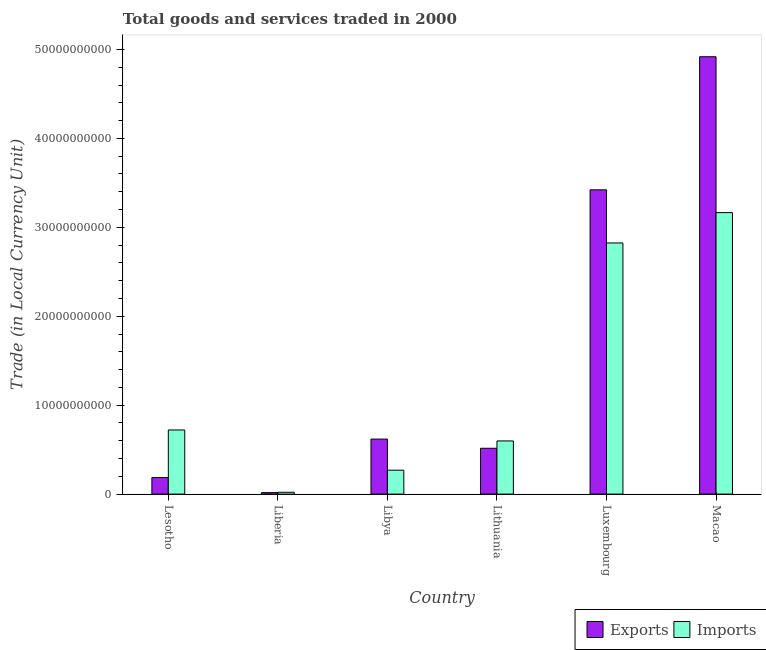How many different coloured bars are there?
Your response must be concise. 2. Are the number of bars on each tick of the X-axis equal?
Your response must be concise. Yes. How many bars are there on the 6th tick from the left?
Give a very brief answer. 2. How many bars are there on the 5th tick from the right?
Your answer should be very brief. 2. What is the label of the 5th group of bars from the left?
Ensure brevity in your answer.  Luxembourg. What is the export of goods and services in Luxembourg?
Your answer should be compact. 3.42e+1. Across all countries, what is the maximum imports of goods and services?
Keep it short and to the point. 3.17e+1. Across all countries, what is the minimum export of goods and services?
Your answer should be compact. 1.66e+08. In which country was the export of goods and services maximum?
Provide a succinct answer. Macao. In which country was the export of goods and services minimum?
Provide a short and direct response. Liberia. What is the total export of goods and services in the graph?
Provide a short and direct response. 9.68e+1. What is the difference between the export of goods and services in Lithuania and that in Luxembourg?
Give a very brief answer. -2.91e+1. What is the difference between the imports of goods and services in Luxembourg and the export of goods and services in Liberia?
Your answer should be compact. 2.81e+1. What is the average imports of goods and services per country?
Keep it short and to the point. 1.27e+1. What is the difference between the export of goods and services and imports of goods and services in Macao?
Offer a terse response. 1.75e+1. In how many countries, is the imports of goods and services greater than 34000000000 LCU?
Provide a succinct answer. 0. What is the ratio of the imports of goods and services in Lesotho to that in Lithuania?
Make the answer very short. 1.21. Is the imports of goods and services in Lithuania less than that in Luxembourg?
Your response must be concise. Yes. Is the difference between the imports of goods and services in Lesotho and Lithuania greater than the difference between the export of goods and services in Lesotho and Lithuania?
Provide a short and direct response. Yes. What is the difference between the highest and the second highest imports of goods and services?
Make the answer very short. 3.41e+09. What is the difference between the highest and the lowest export of goods and services?
Offer a very short reply. 4.90e+1. In how many countries, is the imports of goods and services greater than the average imports of goods and services taken over all countries?
Offer a very short reply. 2. What does the 1st bar from the left in Lithuania represents?
Give a very brief answer. Exports. What does the 2nd bar from the right in Libya represents?
Provide a succinct answer. Exports. How many countries are there in the graph?
Your response must be concise. 6. What is the difference between two consecutive major ticks on the Y-axis?
Your answer should be very brief. 1.00e+1. Are the values on the major ticks of Y-axis written in scientific E-notation?
Your response must be concise. No. Does the graph contain any zero values?
Offer a very short reply. No. How many legend labels are there?
Your response must be concise. 2. How are the legend labels stacked?
Ensure brevity in your answer.  Horizontal. What is the title of the graph?
Offer a very short reply. Total goods and services traded in 2000. What is the label or title of the Y-axis?
Keep it short and to the point. Trade (in Local Currency Unit). What is the Trade (in Local Currency Unit) of Exports in Lesotho?
Provide a short and direct response. 1.86e+09. What is the Trade (in Local Currency Unit) in Imports in Lesotho?
Keep it short and to the point. 7.21e+09. What is the Trade (in Local Currency Unit) in Exports in Liberia?
Provide a succinct answer. 1.66e+08. What is the Trade (in Local Currency Unit) of Imports in Liberia?
Give a very brief answer. 2.06e+08. What is the Trade (in Local Currency Unit) in Exports in Libya?
Your answer should be compact. 6.19e+09. What is the Trade (in Local Currency Unit) of Imports in Libya?
Provide a succinct answer. 2.69e+09. What is the Trade (in Local Currency Unit) of Exports in Lithuania?
Offer a terse response. 5.15e+09. What is the Trade (in Local Currency Unit) of Imports in Lithuania?
Offer a very short reply. 5.98e+09. What is the Trade (in Local Currency Unit) in Exports in Luxembourg?
Make the answer very short. 3.42e+1. What is the Trade (in Local Currency Unit) in Imports in Luxembourg?
Give a very brief answer. 2.82e+1. What is the Trade (in Local Currency Unit) in Exports in Macao?
Your answer should be compact. 4.92e+1. What is the Trade (in Local Currency Unit) in Imports in Macao?
Your answer should be very brief. 3.17e+1. Across all countries, what is the maximum Trade (in Local Currency Unit) in Exports?
Give a very brief answer. 4.92e+1. Across all countries, what is the maximum Trade (in Local Currency Unit) of Imports?
Provide a succinct answer. 3.17e+1. Across all countries, what is the minimum Trade (in Local Currency Unit) in Exports?
Offer a very short reply. 1.66e+08. Across all countries, what is the minimum Trade (in Local Currency Unit) in Imports?
Your response must be concise. 2.06e+08. What is the total Trade (in Local Currency Unit) of Exports in the graph?
Give a very brief answer. 9.68e+1. What is the total Trade (in Local Currency Unit) in Imports in the graph?
Give a very brief answer. 7.60e+1. What is the difference between the Trade (in Local Currency Unit) in Exports in Lesotho and that in Liberia?
Give a very brief answer. 1.70e+09. What is the difference between the Trade (in Local Currency Unit) in Imports in Lesotho and that in Liberia?
Your answer should be compact. 7.00e+09. What is the difference between the Trade (in Local Currency Unit) in Exports in Lesotho and that in Libya?
Ensure brevity in your answer.  -4.32e+09. What is the difference between the Trade (in Local Currency Unit) in Imports in Lesotho and that in Libya?
Give a very brief answer. 4.52e+09. What is the difference between the Trade (in Local Currency Unit) in Exports in Lesotho and that in Lithuania?
Ensure brevity in your answer.  -3.29e+09. What is the difference between the Trade (in Local Currency Unit) in Imports in Lesotho and that in Lithuania?
Provide a short and direct response. 1.23e+09. What is the difference between the Trade (in Local Currency Unit) of Exports in Lesotho and that in Luxembourg?
Provide a succinct answer. -3.23e+1. What is the difference between the Trade (in Local Currency Unit) of Imports in Lesotho and that in Luxembourg?
Provide a succinct answer. -2.10e+1. What is the difference between the Trade (in Local Currency Unit) in Exports in Lesotho and that in Macao?
Keep it short and to the point. -4.73e+1. What is the difference between the Trade (in Local Currency Unit) of Imports in Lesotho and that in Macao?
Your response must be concise. -2.44e+1. What is the difference between the Trade (in Local Currency Unit) of Exports in Liberia and that in Libya?
Give a very brief answer. -6.02e+09. What is the difference between the Trade (in Local Currency Unit) of Imports in Liberia and that in Libya?
Your answer should be compact. -2.48e+09. What is the difference between the Trade (in Local Currency Unit) in Exports in Liberia and that in Lithuania?
Provide a succinct answer. -4.99e+09. What is the difference between the Trade (in Local Currency Unit) in Imports in Liberia and that in Lithuania?
Make the answer very short. -5.77e+09. What is the difference between the Trade (in Local Currency Unit) in Exports in Liberia and that in Luxembourg?
Give a very brief answer. -3.40e+1. What is the difference between the Trade (in Local Currency Unit) of Imports in Liberia and that in Luxembourg?
Offer a very short reply. -2.80e+1. What is the difference between the Trade (in Local Currency Unit) of Exports in Liberia and that in Macao?
Your answer should be compact. -4.90e+1. What is the difference between the Trade (in Local Currency Unit) of Imports in Liberia and that in Macao?
Provide a succinct answer. -3.14e+1. What is the difference between the Trade (in Local Currency Unit) in Exports in Libya and that in Lithuania?
Provide a short and direct response. 1.03e+09. What is the difference between the Trade (in Local Currency Unit) in Imports in Libya and that in Lithuania?
Give a very brief answer. -3.29e+09. What is the difference between the Trade (in Local Currency Unit) of Exports in Libya and that in Luxembourg?
Offer a terse response. -2.80e+1. What is the difference between the Trade (in Local Currency Unit) of Imports in Libya and that in Luxembourg?
Ensure brevity in your answer.  -2.55e+1. What is the difference between the Trade (in Local Currency Unit) in Exports in Libya and that in Macao?
Provide a short and direct response. -4.30e+1. What is the difference between the Trade (in Local Currency Unit) in Imports in Libya and that in Macao?
Your answer should be compact. -2.90e+1. What is the difference between the Trade (in Local Currency Unit) of Exports in Lithuania and that in Luxembourg?
Offer a very short reply. -2.91e+1. What is the difference between the Trade (in Local Currency Unit) in Imports in Lithuania and that in Luxembourg?
Provide a succinct answer. -2.23e+1. What is the difference between the Trade (in Local Currency Unit) of Exports in Lithuania and that in Macao?
Provide a succinct answer. -4.40e+1. What is the difference between the Trade (in Local Currency Unit) of Imports in Lithuania and that in Macao?
Offer a terse response. -2.57e+1. What is the difference between the Trade (in Local Currency Unit) in Exports in Luxembourg and that in Macao?
Keep it short and to the point. -1.50e+1. What is the difference between the Trade (in Local Currency Unit) in Imports in Luxembourg and that in Macao?
Keep it short and to the point. -3.41e+09. What is the difference between the Trade (in Local Currency Unit) in Exports in Lesotho and the Trade (in Local Currency Unit) in Imports in Liberia?
Make the answer very short. 1.66e+09. What is the difference between the Trade (in Local Currency Unit) of Exports in Lesotho and the Trade (in Local Currency Unit) of Imports in Libya?
Your response must be concise. -8.25e+08. What is the difference between the Trade (in Local Currency Unit) of Exports in Lesotho and the Trade (in Local Currency Unit) of Imports in Lithuania?
Your answer should be very brief. -4.11e+09. What is the difference between the Trade (in Local Currency Unit) in Exports in Lesotho and the Trade (in Local Currency Unit) in Imports in Luxembourg?
Your answer should be compact. -2.64e+1. What is the difference between the Trade (in Local Currency Unit) of Exports in Lesotho and the Trade (in Local Currency Unit) of Imports in Macao?
Keep it short and to the point. -2.98e+1. What is the difference between the Trade (in Local Currency Unit) in Exports in Liberia and the Trade (in Local Currency Unit) in Imports in Libya?
Offer a terse response. -2.52e+09. What is the difference between the Trade (in Local Currency Unit) of Exports in Liberia and the Trade (in Local Currency Unit) of Imports in Lithuania?
Ensure brevity in your answer.  -5.81e+09. What is the difference between the Trade (in Local Currency Unit) of Exports in Liberia and the Trade (in Local Currency Unit) of Imports in Luxembourg?
Offer a terse response. -2.81e+1. What is the difference between the Trade (in Local Currency Unit) of Exports in Liberia and the Trade (in Local Currency Unit) of Imports in Macao?
Your response must be concise. -3.15e+1. What is the difference between the Trade (in Local Currency Unit) in Exports in Libya and the Trade (in Local Currency Unit) in Imports in Lithuania?
Provide a short and direct response. 2.07e+08. What is the difference between the Trade (in Local Currency Unit) of Exports in Libya and the Trade (in Local Currency Unit) of Imports in Luxembourg?
Give a very brief answer. -2.21e+1. What is the difference between the Trade (in Local Currency Unit) of Exports in Libya and the Trade (in Local Currency Unit) of Imports in Macao?
Make the answer very short. -2.55e+1. What is the difference between the Trade (in Local Currency Unit) in Exports in Lithuania and the Trade (in Local Currency Unit) in Imports in Luxembourg?
Your response must be concise. -2.31e+1. What is the difference between the Trade (in Local Currency Unit) in Exports in Lithuania and the Trade (in Local Currency Unit) in Imports in Macao?
Offer a very short reply. -2.65e+1. What is the difference between the Trade (in Local Currency Unit) in Exports in Luxembourg and the Trade (in Local Currency Unit) in Imports in Macao?
Offer a very short reply. 2.56e+09. What is the average Trade (in Local Currency Unit) in Exports per country?
Give a very brief answer. 1.61e+1. What is the average Trade (in Local Currency Unit) of Imports per country?
Make the answer very short. 1.27e+1. What is the difference between the Trade (in Local Currency Unit) in Exports and Trade (in Local Currency Unit) in Imports in Lesotho?
Your answer should be compact. -5.35e+09. What is the difference between the Trade (in Local Currency Unit) of Exports and Trade (in Local Currency Unit) of Imports in Liberia?
Provide a succinct answer. -4.00e+07. What is the difference between the Trade (in Local Currency Unit) of Exports and Trade (in Local Currency Unit) of Imports in Libya?
Give a very brief answer. 3.50e+09. What is the difference between the Trade (in Local Currency Unit) in Exports and Trade (in Local Currency Unit) in Imports in Lithuania?
Your answer should be compact. -8.27e+08. What is the difference between the Trade (in Local Currency Unit) of Exports and Trade (in Local Currency Unit) of Imports in Luxembourg?
Your answer should be very brief. 5.97e+09. What is the difference between the Trade (in Local Currency Unit) in Exports and Trade (in Local Currency Unit) in Imports in Macao?
Your response must be concise. 1.75e+1. What is the ratio of the Trade (in Local Currency Unit) of Exports in Lesotho to that in Liberia?
Make the answer very short. 11.23. What is the ratio of the Trade (in Local Currency Unit) of Imports in Lesotho to that in Liberia?
Give a very brief answer. 35. What is the ratio of the Trade (in Local Currency Unit) in Exports in Lesotho to that in Libya?
Your response must be concise. 0.3. What is the ratio of the Trade (in Local Currency Unit) of Imports in Lesotho to that in Libya?
Offer a terse response. 2.68. What is the ratio of the Trade (in Local Currency Unit) in Exports in Lesotho to that in Lithuania?
Give a very brief answer. 0.36. What is the ratio of the Trade (in Local Currency Unit) of Imports in Lesotho to that in Lithuania?
Keep it short and to the point. 1.21. What is the ratio of the Trade (in Local Currency Unit) of Exports in Lesotho to that in Luxembourg?
Keep it short and to the point. 0.05. What is the ratio of the Trade (in Local Currency Unit) in Imports in Lesotho to that in Luxembourg?
Make the answer very short. 0.26. What is the ratio of the Trade (in Local Currency Unit) of Exports in Lesotho to that in Macao?
Ensure brevity in your answer.  0.04. What is the ratio of the Trade (in Local Currency Unit) in Imports in Lesotho to that in Macao?
Keep it short and to the point. 0.23. What is the ratio of the Trade (in Local Currency Unit) in Exports in Liberia to that in Libya?
Offer a very short reply. 0.03. What is the ratio of the Trade (in Local Currency Unit) in Imports in Liberia to that in Libya?
Provide a short and direct response. 0.08. What is the ratio of the Trade (in Local Currency Unit) in Exports in Liberia to that in Lithuania?
Make the answer very short. 0.03. What is the ratio of the Trade (in Local Currency Unit) of Imports in Liberia to that in Lithuania?
Ensure brevity in your answer.  0.03. What is the ratio of the Trade (in Local Currency Unit) of Exports in Liberia to that in Luxembourg?
Offer a very short reply. 0. What is the ratio of the Trade (in Local Currency Unit) of Imports in Liberia to that in Luxembourg?
Make the answer very short. 0.01. What is the ratio of the Trade (in Local Currency Unit) of Exports in Liberia to that in Macao?
Provide a succinct answer. 0. What is the ratio of the Trade (in Local Currency Unit) in Imports in Liberia to that in Macao?
Ensure brevity in your answer.  0.01. What is the ratio of the Trade (in Local Currency Unit) of Exports in Libya to that in Lithuania?
Make the answer very short. 1.2. What is the ratio of the Trade (in Local Currency Unit) of Imports in Libya to that in Lithuania?
Offer a very short reply. 0.45. What is the ratio of the Trade (in Local Currency Unit) of Exports in Libya to that in Luxembourg?
Your response must be concise. 0.18. What is the ratio of the Trade (in Local Currency Unit) in Imports in Libya to that in Luxembourg?
Your answer should be compact. 0.1. What is the ratio of the Trade (in Local Currency Unit) in Exports in Libya to that in Macao?
Your answer should be compact. 0.13. What is the ratio of the Trade (in Local Currency Unit) in Imports in Libya to that in Macao?
Give a very brief answer. 0.09. What is the ratio of the Trade (in Local Currency Unit) in Exports in Lithuania to that in Luxembourg?
Offer a terse response. 0.15. What is the ratio of the Trade (in Local Currency Unit) of Imports in Lithuania to that in Luxembourg?
Your response must be concise. 0.21. What is the ratio of the Trade (in Local Currency Unit) of Exports in Lithuania to that in Macao?
Your answer should be compact. 0.1. What is the ratio of the Trade (in Local Currency Unit) in Imports in Lithuania to that in Macao?
Your answer should be compact. 0.19. What is the ratio of the Trade (in Local Currency Unit) in Exports in Luxembourg to that in Macao?
Give a very brief answer. 0.7. What is the ratio of the Trade (in Local Currency Unit) in Imports in Luxembourg to that in Macao?
Your answer should be very brief. 0.89. What is the difference between the highest and the second highest Trade (in Local Currency Unit) of Exports?
Provide a short and direct response. 1.50e+1. What is the difference between the highest and the second highest Trade (in Local Currency Unit) in Imports?
Provide a short and direct response. 3.41e+09. What is the difference between the highest and the lowest Trade (in Local Currency Unit) in Exports?
Provide a short and direct response. 4.90e+1. What is the difference between the highest and the lowest Trade (in Local Currency Unit) of Imports?
Provide a succinct answer. 3.14e+1. 